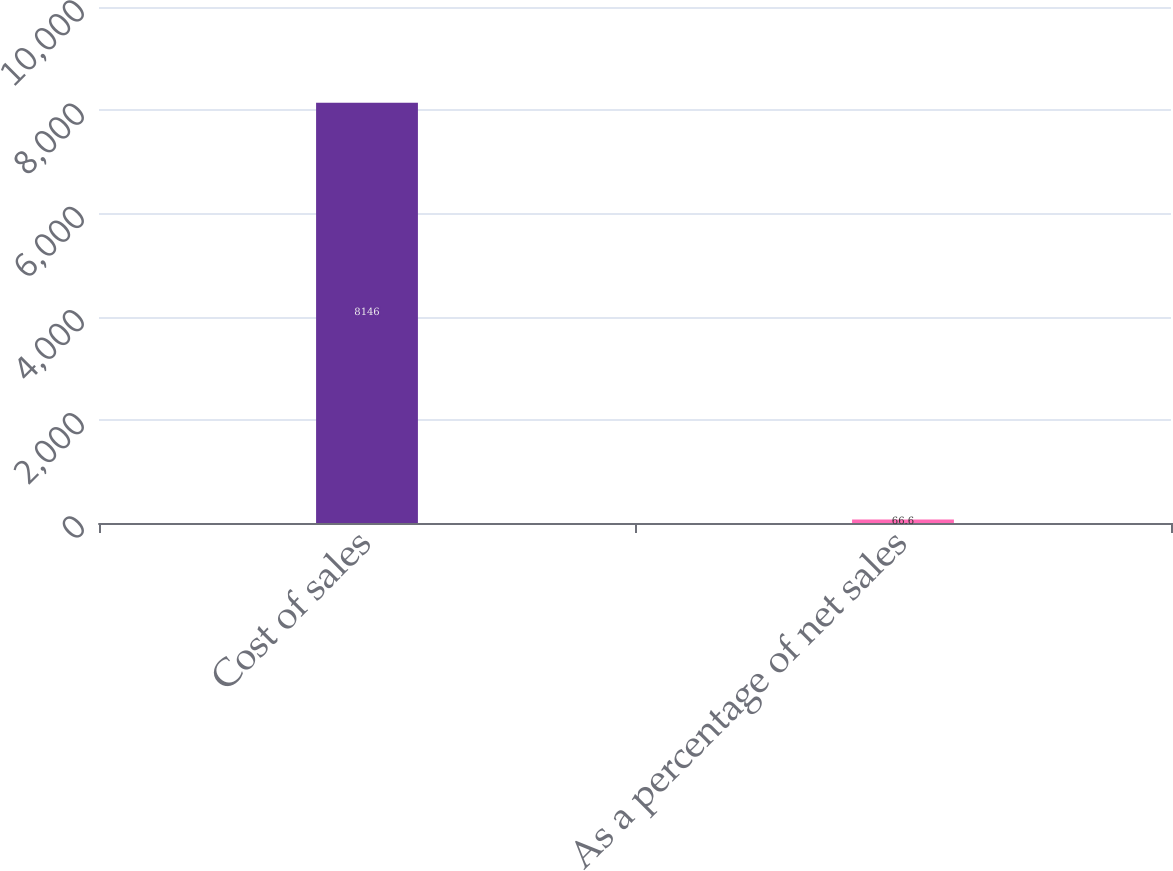Convert chart. <chart><loc_0><loc_0><loc_500><loc_500><bar_chart><fcel>Cost of sales<fcel>As a percentage of net sales<nl><fcel>8146<fcel>66.6<nl></chart> 